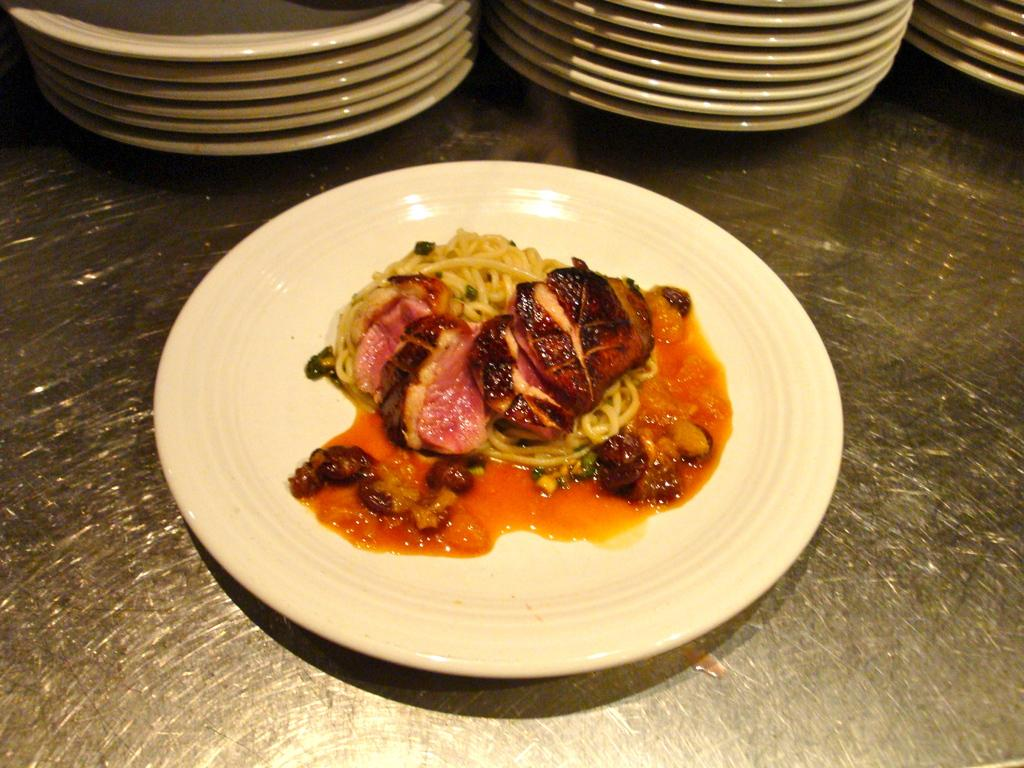What is placed on the plate in the image? There is food placed in a plate in the image. Where is the plate located in the image? The plate is placed on a surface. Can you describe the arrangement of plates in the image? There are additional plates arranged in the backdrop of the image. What type of appliance is floating in the clouds in the image? There is no appliance or clouds present in the image; it only features a plate with food and additional plates in the backdrop. 